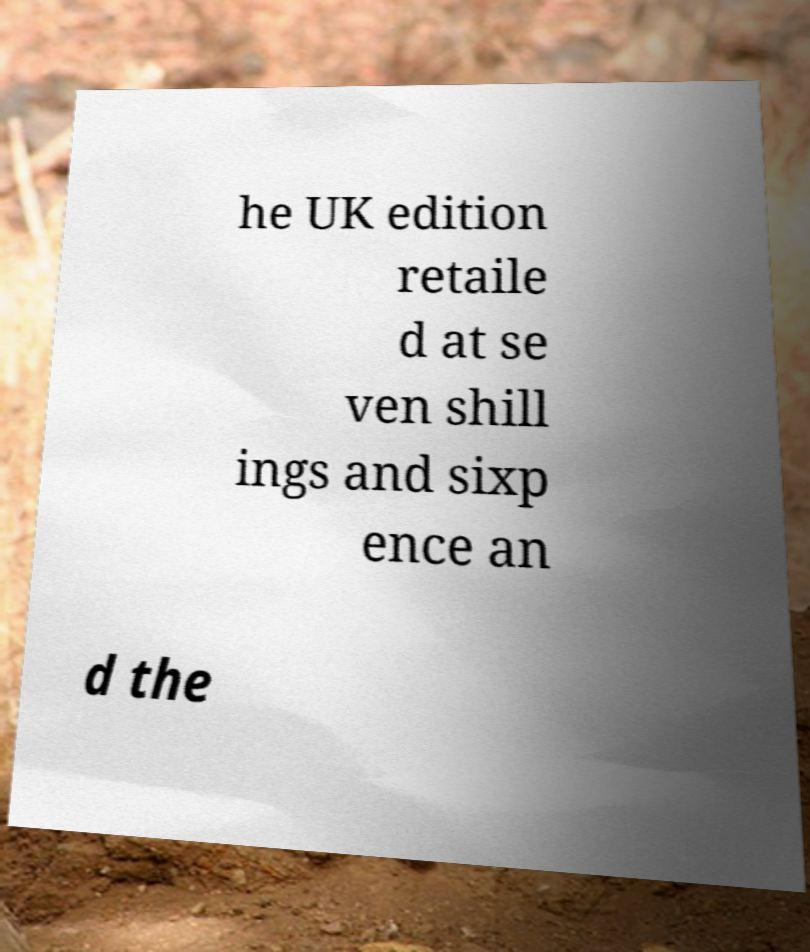Please read and relay the text visible in this image. What does it say? he UK edition retaile d at se ven shill ings and sixp ence an d the 